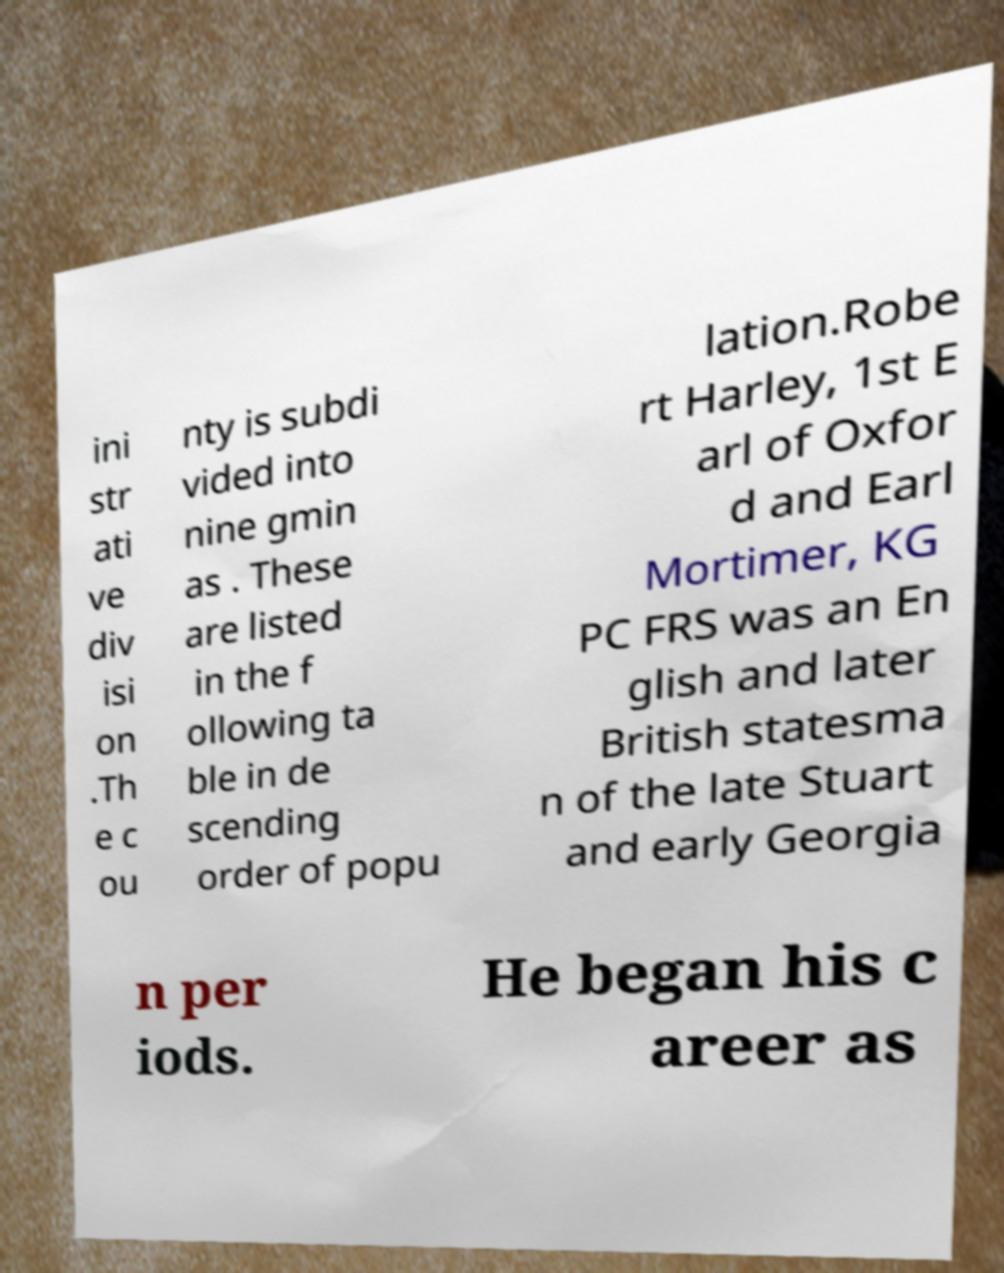What messages or text are displayed in this image? I need them in a readable, typed format. ini str ati ve div isi on .Th e c ou nty is subdi vided into nine gmin as . These are listed in the f ollowing ta ble in de scending order of popu lation.Robe rt Harley, 1st E arl of Oxfor d and Earl Mortimer, KG PC FRS was an En glish and later British statesma n of the late Stuart and early Georgia n per iods. He began his c areer as 